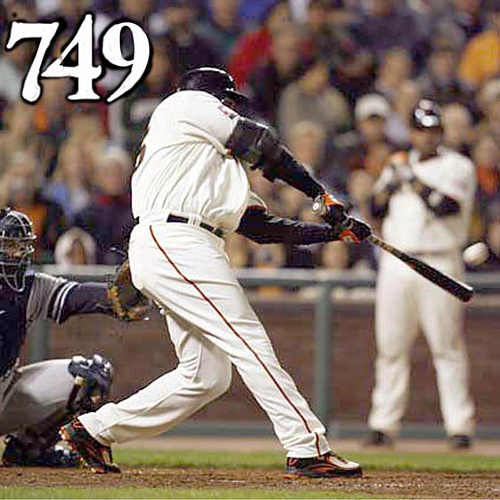Describe the objects in this image and their specific colors. I can see people in black, white, darkgray, and gray tones, people in black, lightgray, darkgray, gray, and tan tones, people in black, gray, and darkgray tones, people in black, gray, and maroon tones, and baseball glove in black, maroon, and gray tones in this image. 